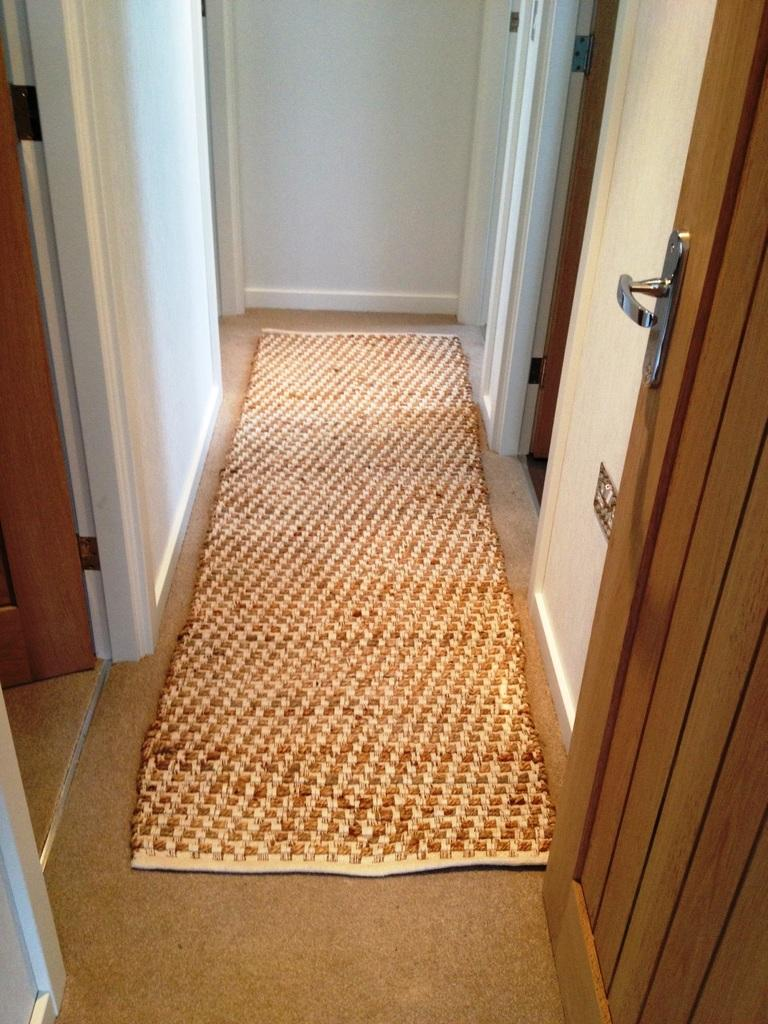What is located in the center of the image? There is a rug in the center of the image. What can be seen on the right side of the image? There is a door on the right side of the image. What is present on the left side of the image? There is a door on the left side of the image. What type of cup is being used to talk in the image? There is no cup or talking present in the image; it only features a rug and two doors. 